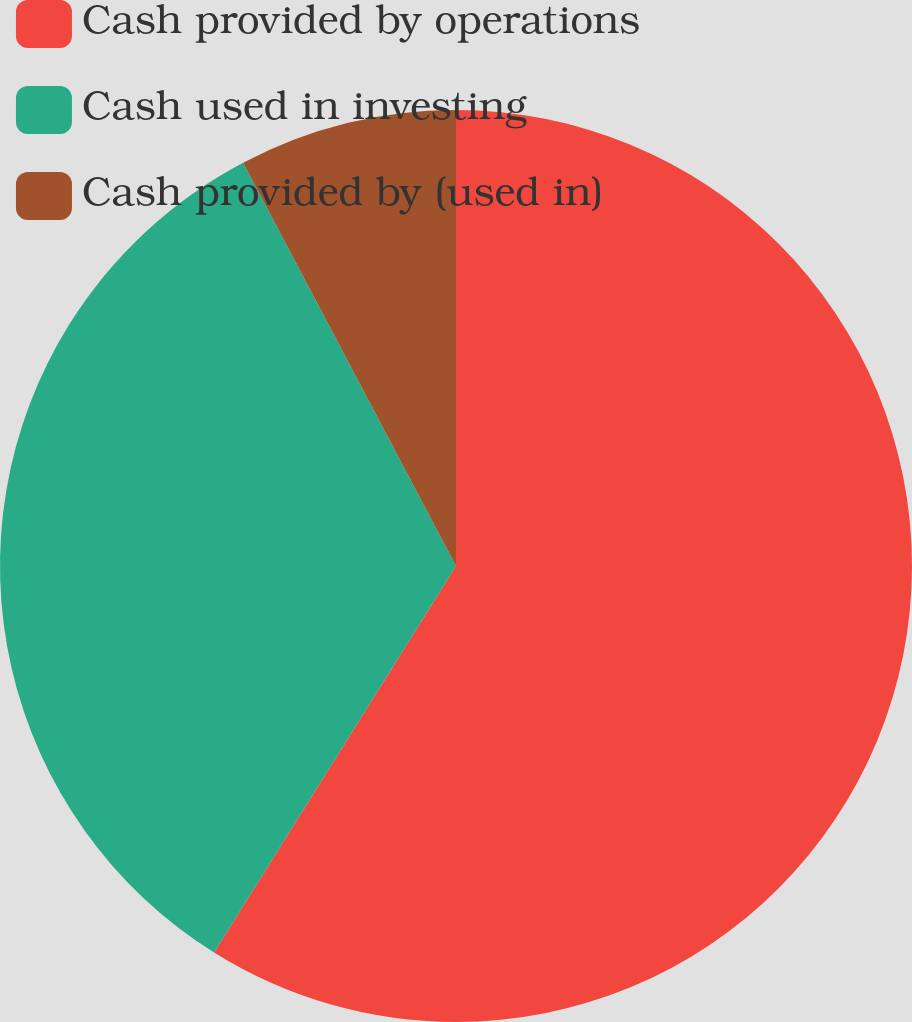Convert chart to OTSL. <chart><loc_0><loc_0><loc_500><loc_500><pie_chart><fcel>Cash provided by operations<fcel>Cash used in investing<fcel>Cash provided by (used in)<nl><fcel>58.9%<fcel>33.37%<fcel>7.73%<nl></chart> 